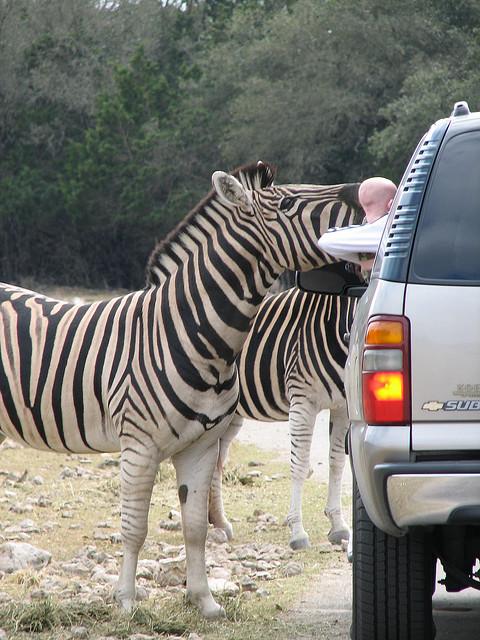Why are the zebras approaching the car?
Short answer required. Curiosity. Is that a baby hanging out of the window?
Short answer required. Yes. Are the zebras charging the vehicle?
Keep it brief. No. How many zebras are in the picture?
Keep it brief. 2. 